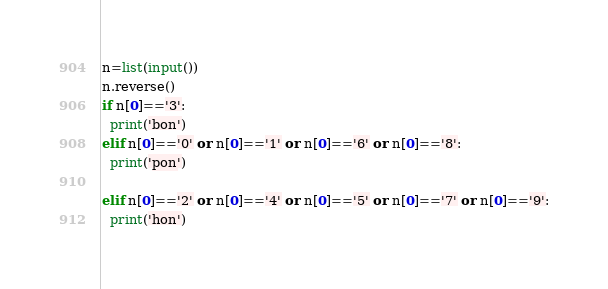<code> <loc_0><loc_0><loc_500><loc_500><_Python_>n=list(input())
n.reverse()
if n[0]=='3':
  print('bon')
elif n[0]=='0' or n[0]=='1' or n[0]=='6' or n[0]=='8':
  print('pon')
  
elif n[0]=='2' or n[0]=='4' or n[0]=='5' or n[0]=='7' or n[0]=='9':
  print('hon')</code> 